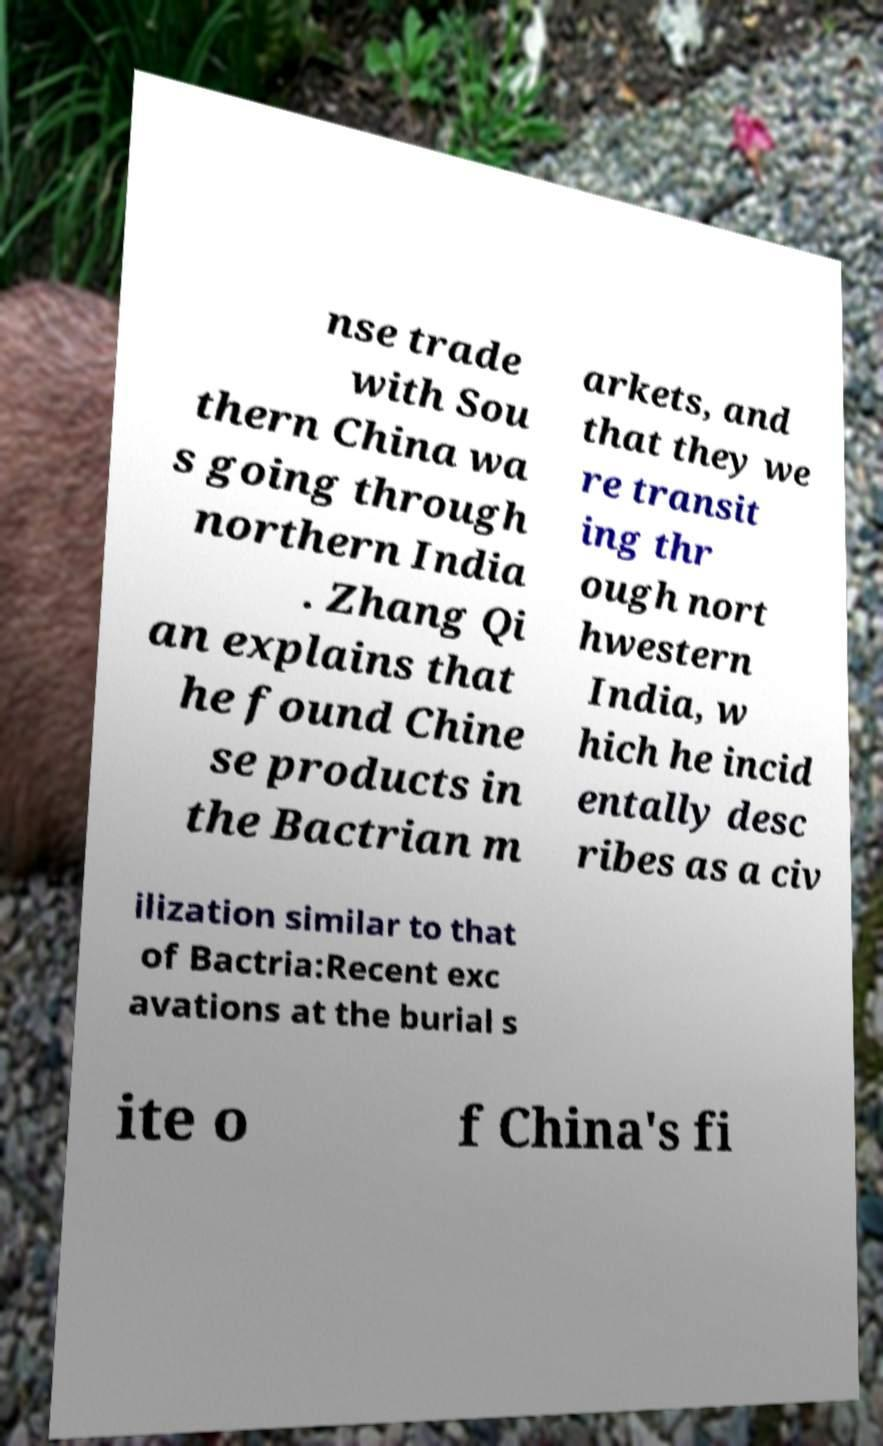Could you extract and type out the text from this image? nse trade with Sou thern China wa s going through northern India . Zhang Qi an explains that he found Chine se products in the Bactrian m arkets, and that they we re transit ing thr ough nort hwestern India, w hich he incid entally desc ribes as a civ ilization similar to that of Bactria:Recent exc avations at the burial s ite o f China's fi 